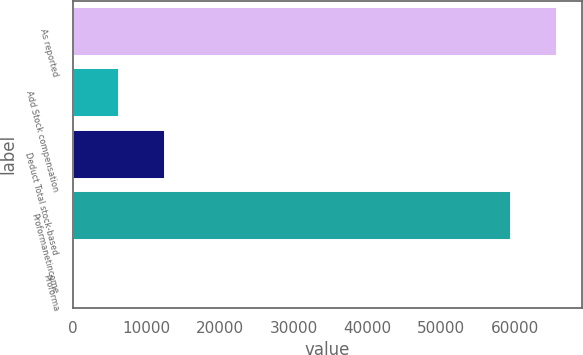Convert chart to OTSL. <chart><loc_0><loc_0><loc_500><loc_500><bar_chart><fcel>As reported<fcel>Add Stock compensation<fcel>Deduct Total stock-based<fcel>Proformanetincome<fcel>Proforma<nl><fcel>65742.1<fcel>6245.73<fcel>12489.9<fcel>59498<fcel>1.59<nl></chart> 